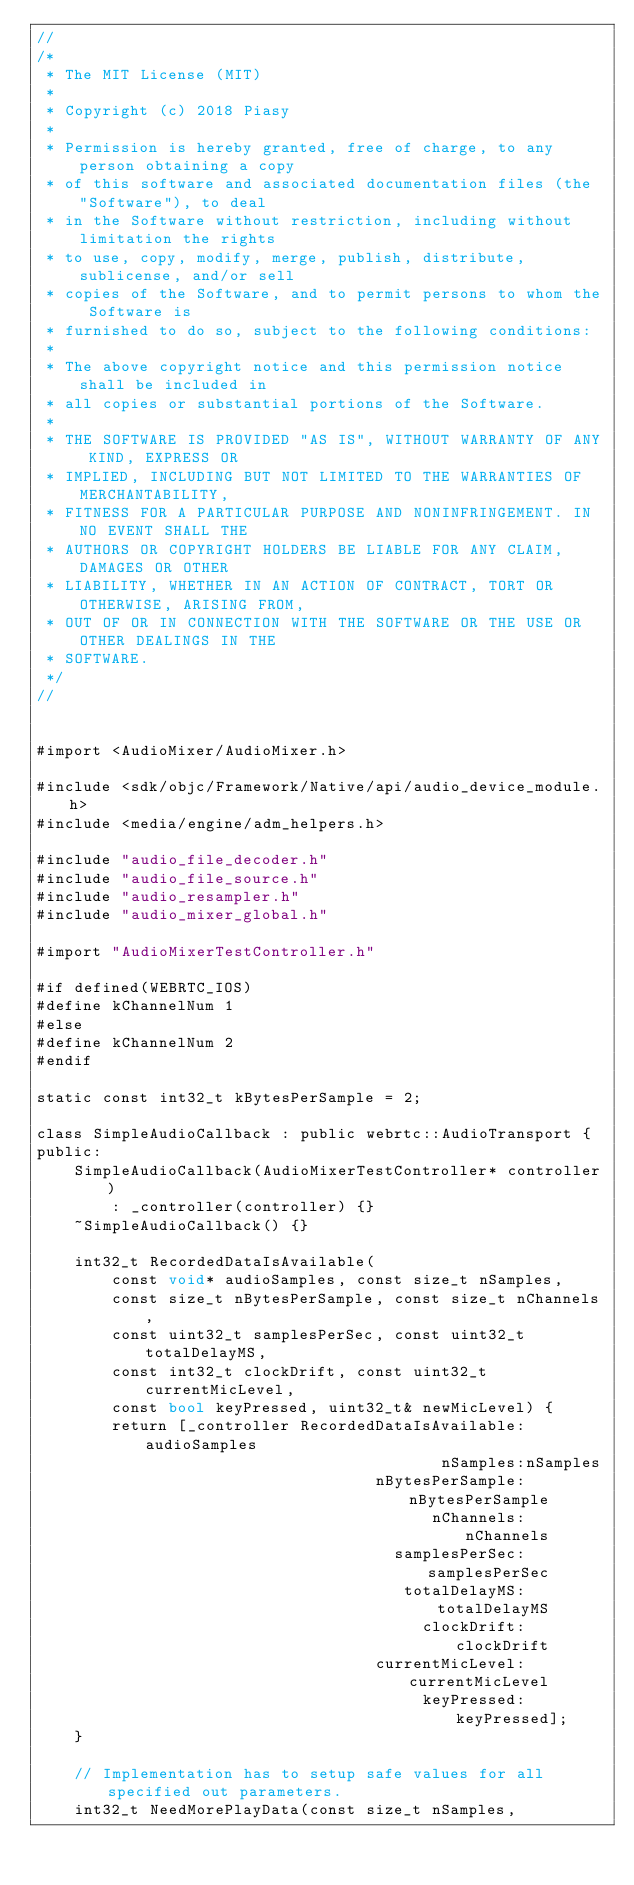Convert code to text. <code><loc_0><loc_0><loc_500><loc_500><_ObjectiveC_>//
/*
 * The MIT License (MIT)
 *
 * Copyright (c) 2018 Piasy
 *
 * Permission is hereby granted, free of charge, to any person obtaining a copy
 * of this software and associated documentation files (the "Software"), to deal
 * in the Software without restriction, including without limitation the rights
 * to use, copy, modify, merge, publish, distribute, sublicense, and/or sell
 * copies of the Software, and to permit persons to whom the Software is
 * furnished to do so, subject to the following conditions:
 *
 * The above copyright notice and this permission notice shall be included in
 * all copies or substantial portions of the Software.
 *
 * THE SOFTWARE IS PROVIDED "AS IS", WITHOUT WARRANTY OF ANY KIND, EXPRESS OR
 * IMPLIED, INCLUDING BUT NOT LIMITED TO THE WARRANTIES OF MERCHANTABILITY,
 * FITNESS FOR A PARTICULAR PURPOSE AND NONINFRINGEMENT. IN NO EVENT SHALL THE
 * AUTHORS OR COPYRIGHT HOLDERS BE LIABLE FOR ANY CLAIM, DAMAGES OR OTHER
 * LIABILITY, WHETHER IN AN ACTION OF CONTRACT, TORT OR OTHERWISE, ARISING FROM,
 * OUT OF OR IN CONNECTION WITH THE SOFTWARE OR THE USE OR OTHER DEALINGS IN THE
 * SOFTWARE.
 */
//


#import <AudioMixer/AudioMixer.h>

#include <sdk/objc/Framework/Native/api/audio_device_module.h>
#include <media/engine/adm_helpers.h>

#include "audio_file_decoder.h"
#include "audio_file_source.h"
#include "audio_resampler.h"
#include "audio_mixer_global.h"

#import "AudioMixerTestController.h"

#if defined(WEBRTC_IOS)
#define kChannelNum 1
#else
#define kChannelNum 2
#endif

static const int32_t kBytesPerSample = 2;

class SimpleAudioCallback : public webrtc::AudioTransport {
public:
    SimpleAudioCallback(AudioMixerTestController* controller)
        : _controller(controller) {}
    ~SimpleAudioCallback() {}

    int32_t RecordedDataIsAvailable(
        const void* audioSamples, const size_t nSamples,
        const size_t nBytesPerSample, const size_t nChannels,
        const uint32_t samplesPerSec, const uint32_t totalDelayMS,
        const int32_t clockDrift, const uint32_t currentMicLevel,
        const bool keyPressed, uint32_t& newMicLevel) {
        return [_controller RecordedDataIsAvailable:audioSamples
                                           nSamples:nSamples
                                    nBytesPerSample:nBytesPerSample
                                          nChannels:nChannels
                                      samplesPerSec:samplesPerSec
                                       totalDelayMS:totalDelayMS
                                         clockDrift:clockDrift
                                    currentMicLevel:currentMicLevel
                                         keyPressed:keyPressed];
    }

    // Implementation has to setup safe values for all specified out parameters.
    int32_t NeedMorePlayData(const size_t nSamples,</code> 